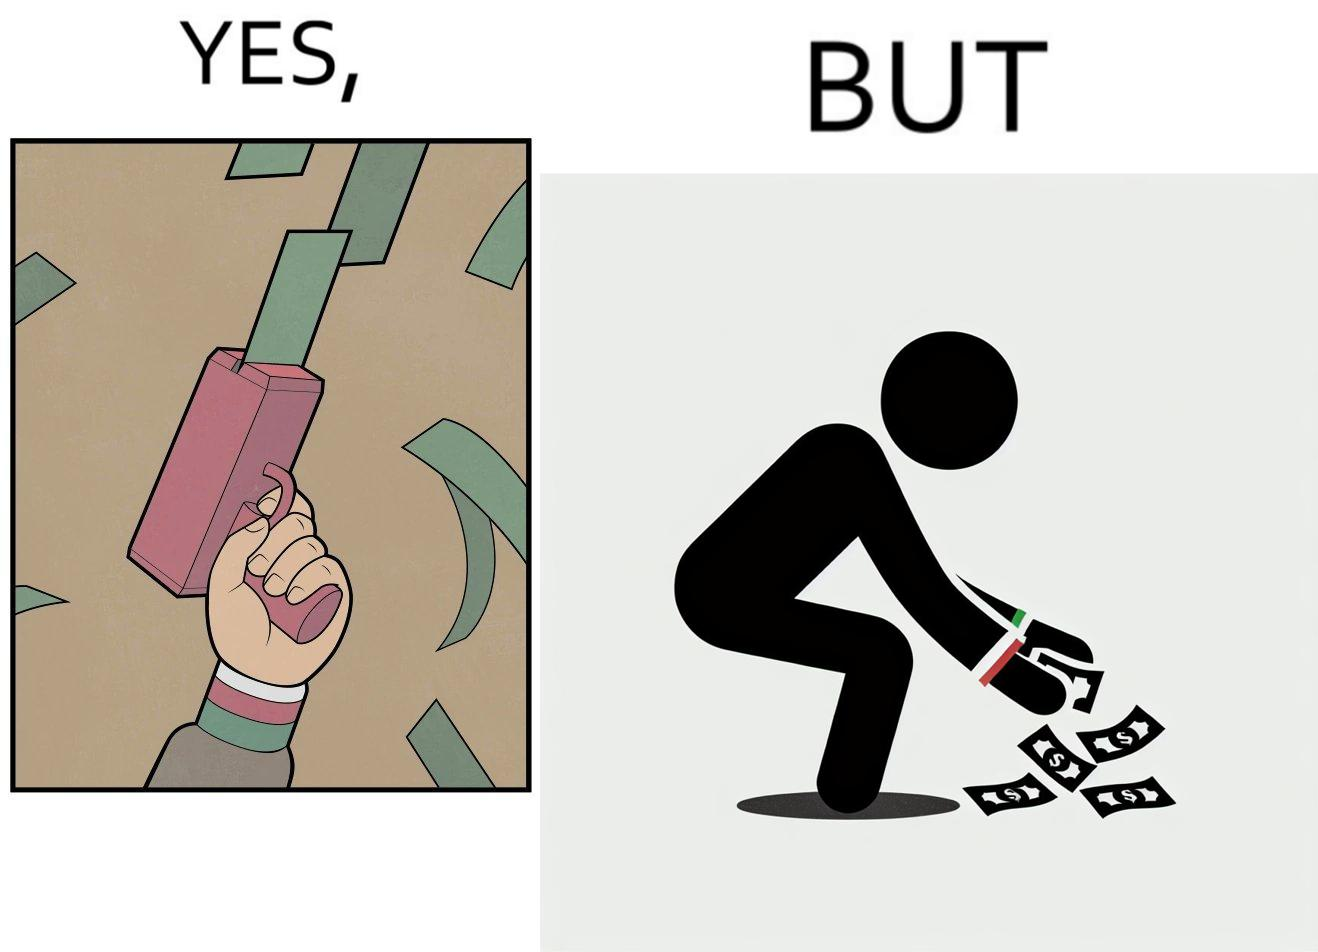Explain why this image is satirical. The image is satirical because the man that is shooting money in the air causing a rain of money bills is the same person who is crouching down to collect the fallen dollar bills from the ground which makes the act of shooting bills in the air not so fun. 